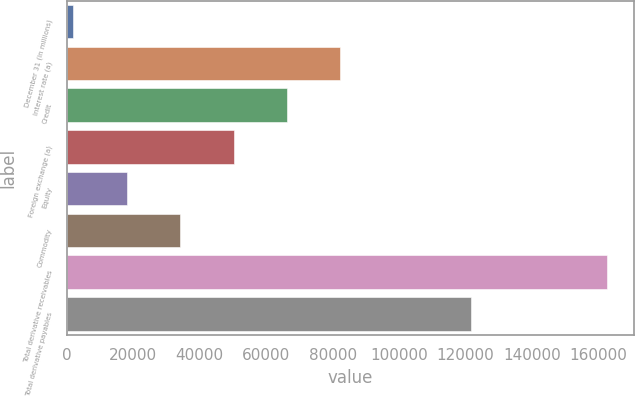Convert chart. <chart><loc_0><loc_0><loc_500><loc_500><bar_chart><fcel>December 31 (in millions)<fcel>Interest rate (a)<fcel>Credit<fcel>Foreign exchange (a)<fcel>Equity<fcel>Commodity<fcel>Total derivative receivables<fcel>Total derivative payables<nl><fcel>2008<fcel>82317<fcel>66255.2<fcel>50193.4<fcel>18069.8<fcel>34131.6<fcel>162626<fcel>121604<nl></chart> 